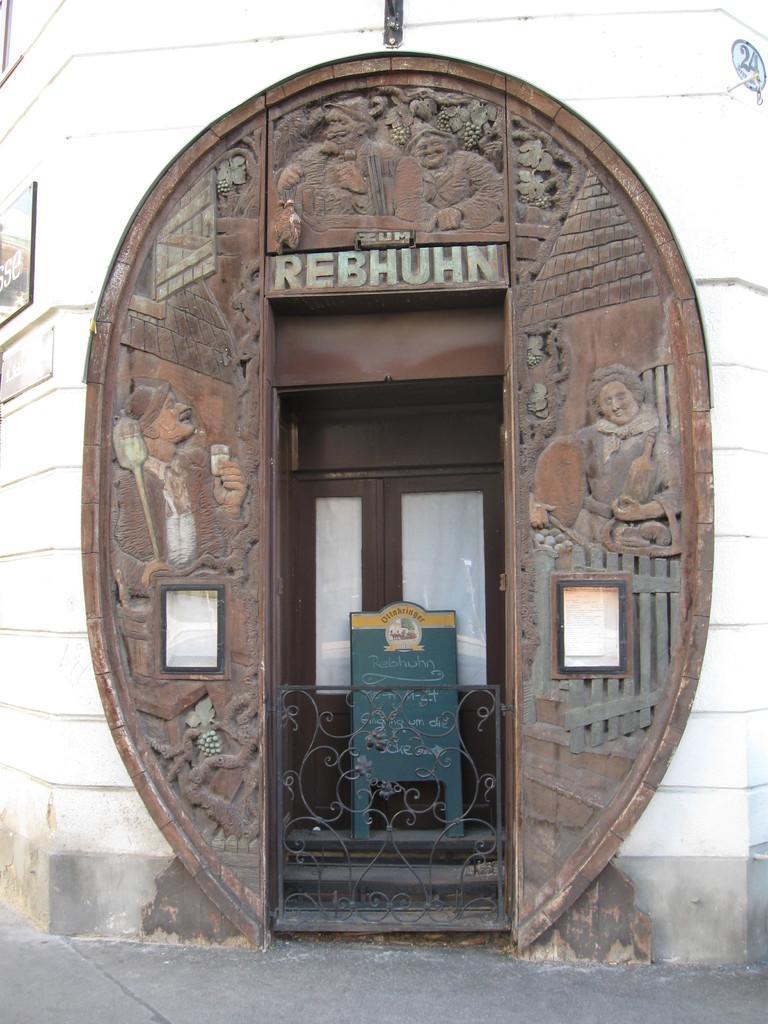Please provide a concise description of this image. In the middle of the image we can see few metal rods, board and doors, on the left side of the image we can find few posters on the wall. 